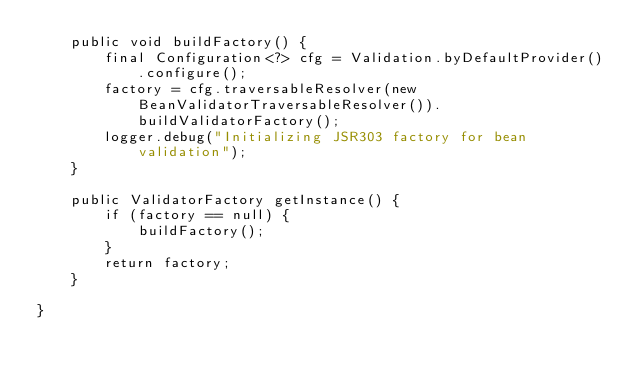Convert code to text. <code><loc_0><loc_0><loc_500><loc_500><_Java_>	public void buildFactory() {
		final Configuration<?> cfg = Validation.byDefaultProvider().configure();
        factory = cfg.traversableResolver(new BeanValidatorTraversableResolver()).buildValidatorFactory();
        logger.debug("Initializing JSR303 factory for bean validation");
	}

	public ValidatorFactory getInstance() {
		if (factory == null) {
			buildFactory();
		}
		return factory;
	}

}
</code> 